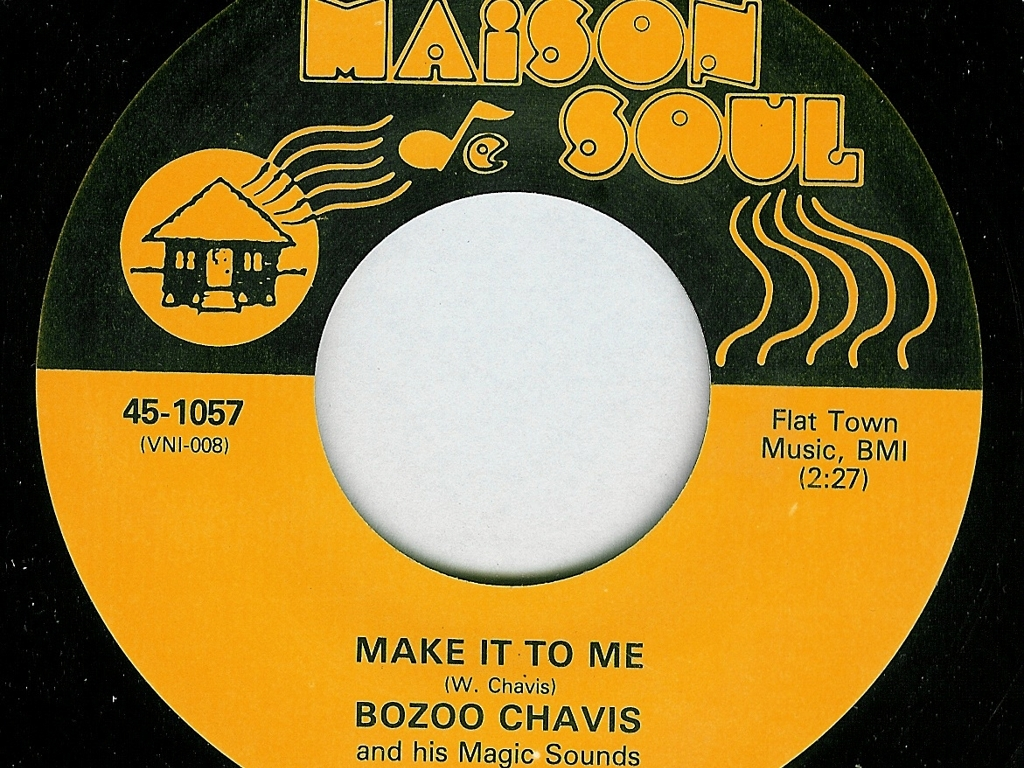Is there any image blur?
A. Yes
B. No
Answer with the option's letter from the given choices directly.
 B. 